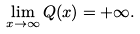<formula> <loc_0><loc_0><loc_500><loc_500>\lim _ { x \to \infty } Q ( x ) = + \infty .</formula> 